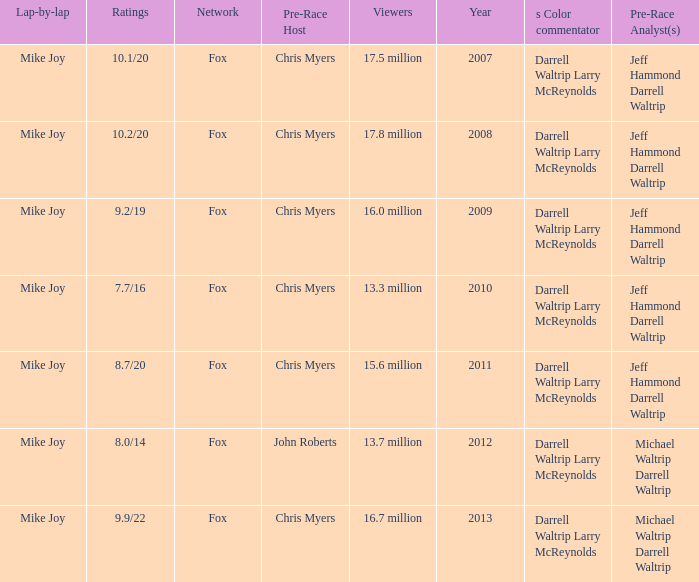How many Ratings did the 2013 Year have? 9.9/22. 